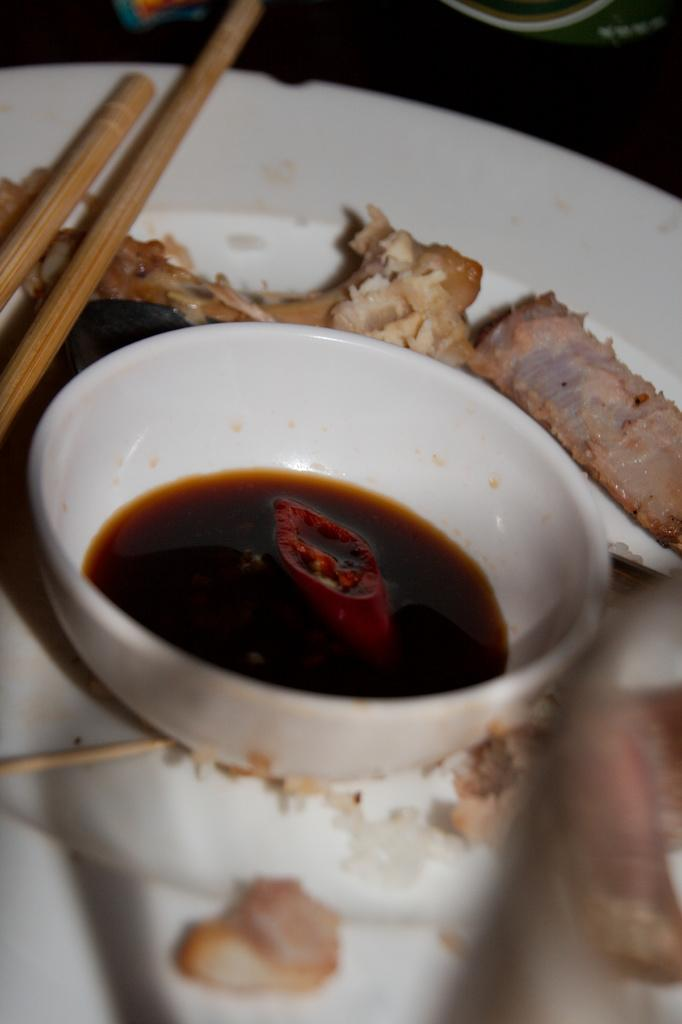What is present on the plate in the image? There is a plate in the image, and there is food on the plate. What else is on the plate besides the food? There is a bowl on the plate. What is inside the bowl on the plate? There are spoons in the bowl. Where is the drawer located in the image? There is no drawer present in the image. What type of throat is visible in the image? There is no throat visible in the image. 